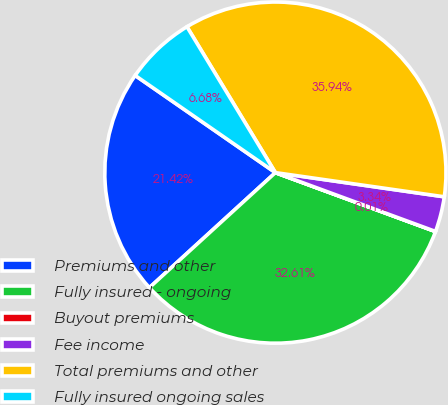Convert chart to OTSL. <chart><loc_0><loc_0><loc_500><loc_500><pie_chart><fcel>Premiums and other<fcel>Fully insured - ongoing<fcel>Buyout premiums<fcel>Fee income<fcel>Total premiums and other<fcel>Fully insured ongoing sales<nl><fcel>21.42%<fcel>32.61%<fcel>0.01%<fcel>3.34%<fcel>35.94%<fcel>6.68%<nl></chart> 